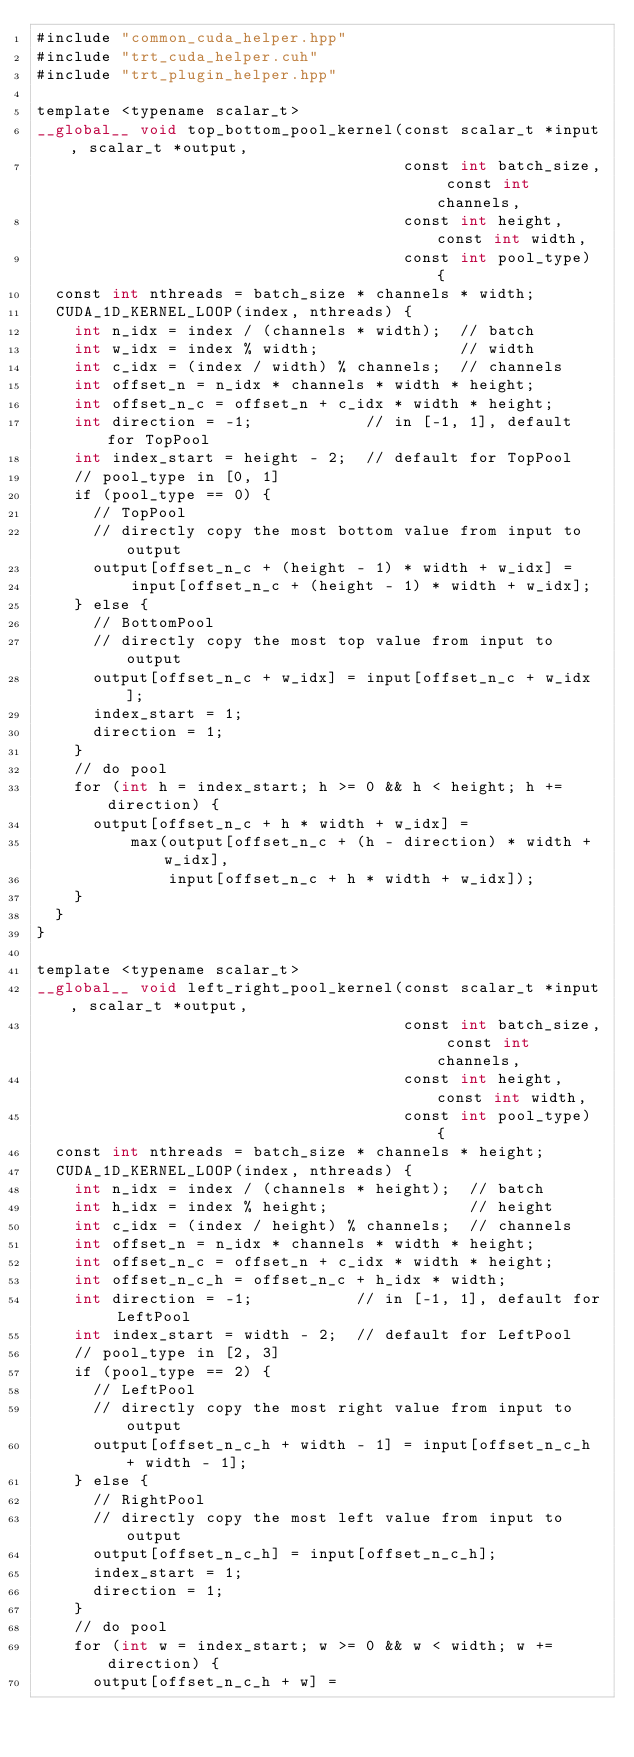<code> <loc_0><loc_0><loc_500><loc_500><_Cuda_>#include "common_cuda_helper.hpp"
#include "trt_cuda_helper.cuh"
#include "trt_plugin_helper.hpp"

template <typename scalar_t>
__global__ void top_bottom_pool_kernel(const scalar_t *input, scalar_t *output,
                                       const int batch_size, const int channels,
                                       const int height, const int width,
                                       const int pool_type) {
  const int nthreads = batch_size * channels * width;
  CUDA_1D_KERNEL_LOOP(index, nthreads) {
    int n_idx = index / (channels * width);  // batch
    int w_idx = index % width;               // width
    int c_idx = (index / width) % channels;  // channels
    int offset_n = n_idx * channels * width * height;
    int offset_n_c = offset_n + c_idx * width * height;
    int direction = -1;            // in [-1, 1], default for TopPool
    int index_start = height - 2;  // default for TopPool
    // pool_type in [0, 1]
    if (pool_type == 0) {
      // TopPool
      // directly copy the most bottom value from input to output
      output[offset_n_c + (height - 1) * width + w_idx] =
          input[offset_n_c + (height - 1) * width + w_idx];
    } else {
      // BottomPool
      // directly copy the most top value from input to output
      output[offset_n_c + w_idx] = input[offset_n_c + w_idx];
      index_start = 1;
      direction = 1;
    }
    // do pool
    for (int h = index_start; h >= 0 && h < height; h += direction) {
      output[offset_n_c + h * width + w_idx] =
          max(output[offset_n_c + (h - direction) * width + w_idx],
              input[offset_n_c + h * width + w_idx]);
    }
  }
}

template <typename scalar_t>
__global__ void left_right_pool_kernel(const scalar_t *input, scalar_t *output,
                                       const int batch_size, const int channels,
                                       const int height, const int width,
                                       const int pool_type) {
  const int nthreads = batch_size * channels * height;
  CUDA_1D_KERNEL_LOOP(index, nthreads) {
    int n_idx = index / (channels * height);  // batch
    int h_idx = index % height;               // height
    int c_idx = (index / height) % channels;  // channels
    int offset_n = n_idx * channels * width * height;
    int offset_n_c = offset_n + c_idx * width * height;
    int offset_n_c_h = offset_n_c + h_idx * width;
    int direction = -1;           // in [-1, 1], default for LeftPool
    int index_start = width - 2;  // default for LeftPool
    // pool_type in [2, 3]
    if (pool_type == 2) {
      // LeftPool
      // directly copy the most right value from input to output
      output[offset_n_c_h + width - 1] = input[offset_n_c_h + width - 1];
    } else {
      // RightPool
      // directly copy the most left value from input to output
      output[offset_n_c_h] = input[offset_n_c_h];
      index_start = 1;
      direction = 1;
    }
    // do pool
    for (int w = index_start; w >= 0 && w < width; w += direction) {
      output[offset_n_c_h + w] =</code> 